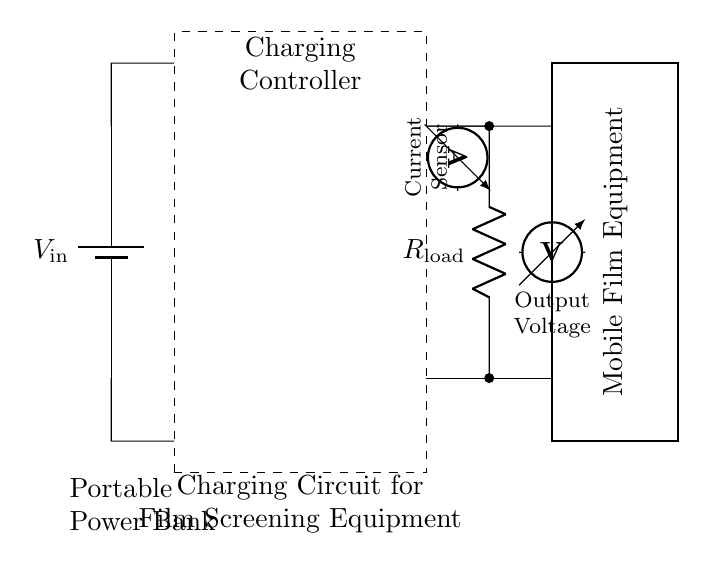What is the input voltage in this circuit? The input voltage is indicated as "V_in" in the circuit diagram, positioned at the top left near the battery symbol.
Answer: V_in What does the dashed rectangle represent? The dashed rectangle outlines the Charging Controller, which is labeled directly inside the box and is responsible for managing power to the mobile film screening equipment.
Answer: Charging Controller What type of sensor is used in this circuit? The circuit includes a current sensor, which is represented by the ammeter symbol located to the left of the output voltage path, indicating it measures the current flow in the circuit.
Answer: Current sensor What is the relationship between the load resistor and the output voltage? The load resistor (R_load) is placed in the circuit such that the output voltage can be measured across it, allowing the current flowing through the resistor to affect the voltage drop. Thus, the value of R_load directly influences the output voltage experienced by the mobile film equipment.
Answer: Output voltage depends on R_load How is the mobile film screening equipment powered in this circuit? The mobile film screening equipment receives power from the output of the charging controller through two output lines, as indicated in the diagram, and is connected to the load resistor, which allows it to function by utilizing the stored energy from the power bank.
Answer: Through output lines What components are required to make this charging circuit functional? The essential components include a portable power bank providing the input voltage, a charging controller managing the power flow, a load resistor representing the mobile film equipment, and sensors to monitor the current and voltage. Each component plays a crucial role in ensuring the circuit operates correctly.
Answer: Power bank, charging controller, load resistor, sensors 